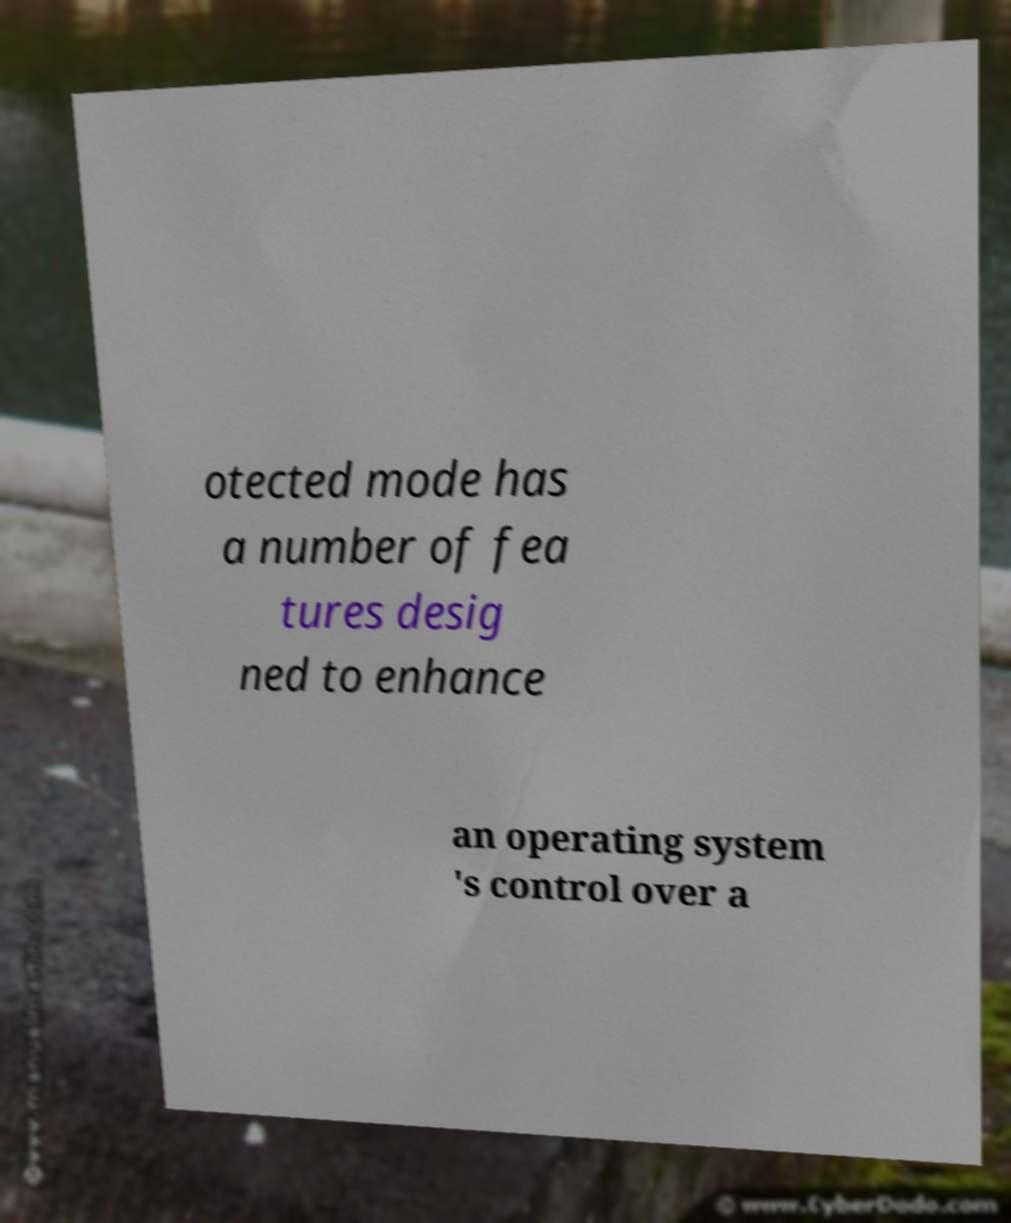Can you read and provide the text displayed in the image?This photo seems to have some interesting text. Can you extract and type it out for me? otected mode has a number of fea tures desig ned to enhance an operating system 's control over a 